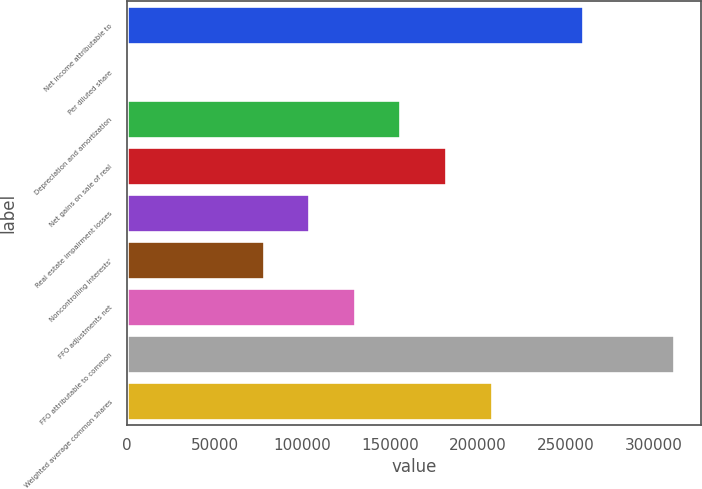Convert chart. <chart><loc_0><loc_0><loc_500><loc_500><bar_chart><fcel>Net income attributable to<fcel>Per diluted share<fcel>Depreciation and amortization<fcel>Net gains on sale of real<fcel>Real estate impairment losses<fcel>Noncontrolling interests'<fcel>FFO adjustments net<fcel>FFO attributable to common<fcel>Weighted average common shares<nl><fcel>259528<fcel>1.22<fcel>155717<fcel>181670<fcel>103812<fcel>77859.3<fcel>129765<fcel>311433<fcel>207623<nl></chart> 